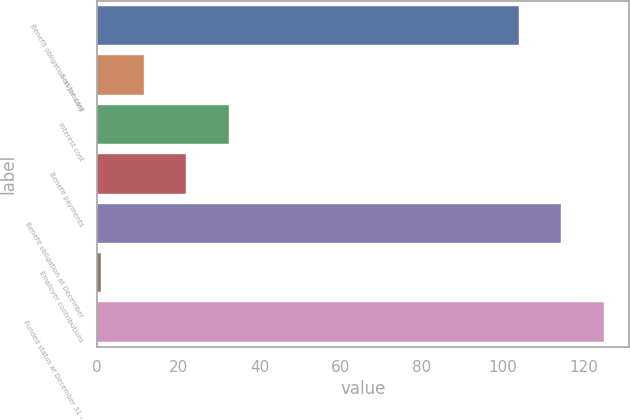Convert chart. <chart><loc_0><loc_0><loc_500><loc_500><bar_chart><fcel>Benefit obligation at January<fcel>Service cost<fcel>Interest cost<fcel>Benefit payments<fcel>Benefit obligation at December<fcel>Employer contributions<fcel>Funded status at December 31 -<nl><fcel>104<fcel>11.5<fcel>32.5<fcel>22<fcel>114.5<fcel>1<fcel>125<nl></chart> 